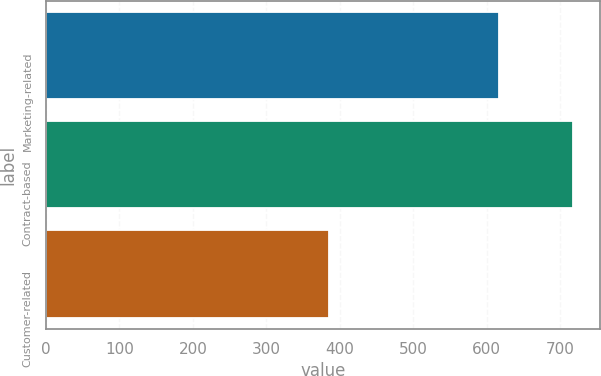Convert chart. <chart><loc_0><loc_0><loc_500><loc_500><bar_chart><fcel>Marketing-related<fcel>Contract-based<fcel>Customer-related<nl><fcel>616<fcel>718<fcel>385<nl></chart> 